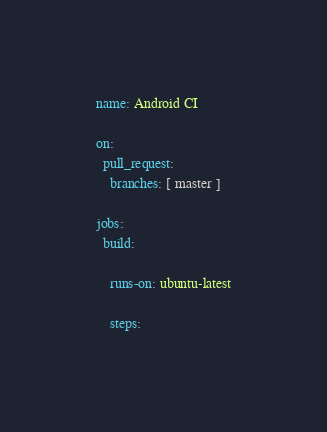<code> <loc_0><loc_0><loc_500><loc_500><_YAML_>name: Android CI

on:
  pull_request:
    branches: [ master ]

jobs:
  build:

    runs-on: ubuntu-latest

    steps:</code> 